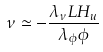<formula> <loc_0><loc_0><loc_500><loc_500>\nu \simeq - \frac { \lambda _ { \nu } L H _ { u } } { \lambda _ { \phi } \phi }</formula> 